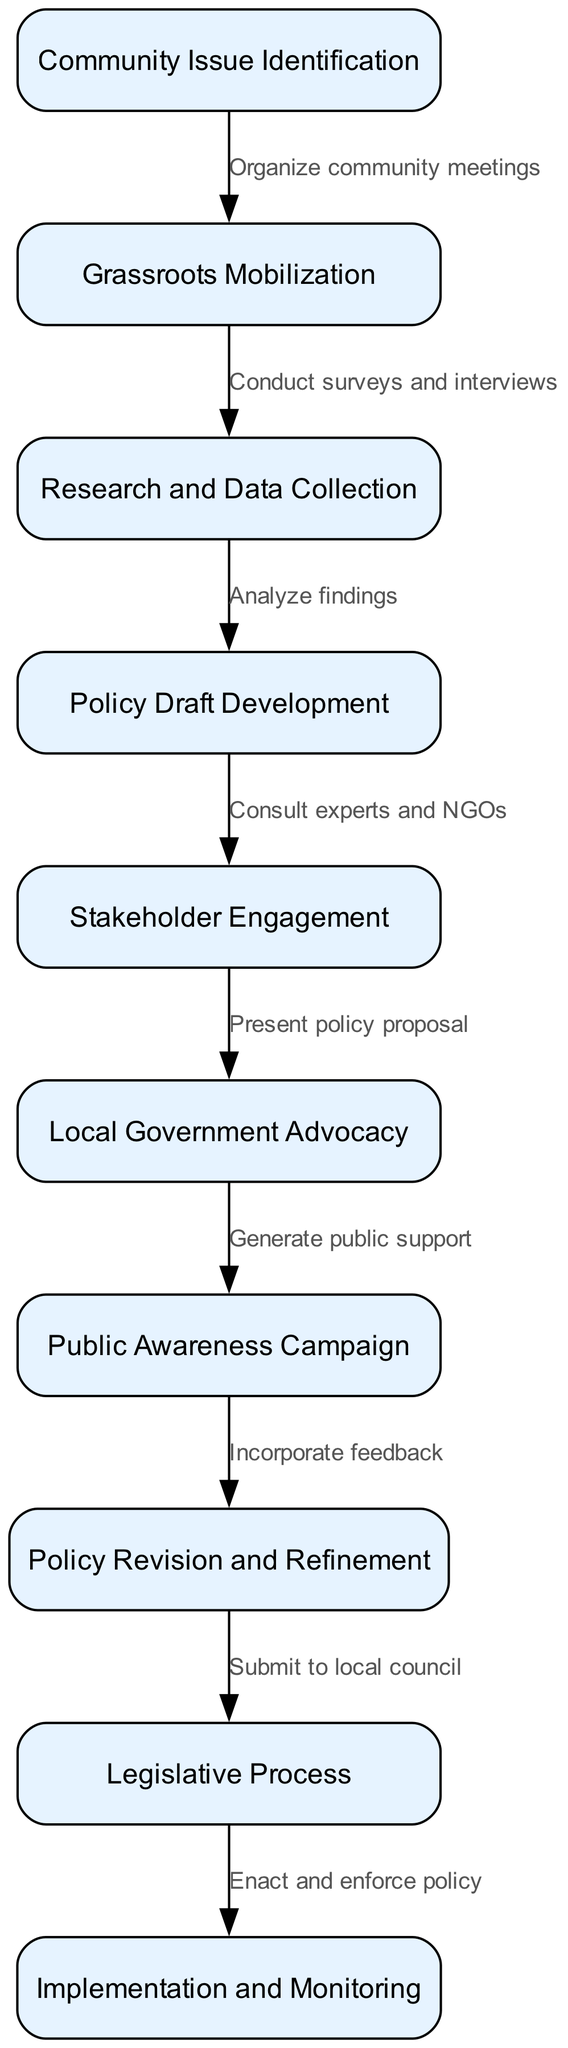What is the first step in the policy reform process? The first step in the process is "Community Issue Identification," which is indicated as the starting node in the diagram.
Answer: Community Issue Identification How many nodes are there in the diagram? The diagram contains a total of 10 nodes, which represent different steps in the community-led policy reform process.
Answer: 10 What label is associated with the edge from "Grassroots Mobilization" to "Research and Data Collection"? The edge connecting "Grassroots Mobilization" to "Research and Data Collection" is labeled "Conduct surveys and interviews," describing the action taken to gather information.
Answer: Conduct surveys and interviews Which step follows "Policy Draft Development"? The step that follows "Policy Draft Development" is "Stakeholder Engagement," as indicated by the directed edge connecting these two nodes in the process flow.
Answer: Stakeholder Engagement What is the final step in the policy reform process? The final step in the process is "Implementation and Monitoring," which follows the legislative procedures and indicates the concluding phase of the reform initiative.
Answer: Implementation and Monitoring How many edges are there in the diagram? The diagram consists of 9 edges, which represent the connections and flow between different steps in the policy reform process.
Answer: 9 What is the relationship between "Local Government Advocacy" and "Public Awareness Campaign"? The relationship is that "Local Government Advocacy" leads to "Public Awareness Campaign," as indicated by the edge that describes the action of generating public support after presenting policy proposals to local authorities.
Answer: Generate public support What is required after receiving feedback on the "Public Awareness Campaign"? After receiving feedback, the next required action is "Policy Revision and Refinement," where the gathered input is incorporated to enhance the policy proposal.
Answer: Incorporate feedback What node requires presenting the policy proposal? The "Stakeholder Engagement" node requires presenting the policy proposal, as that's the action taken after developing the policy draft in consultation with stakeholders and experts.
Answer: Stakeholder Engagement 